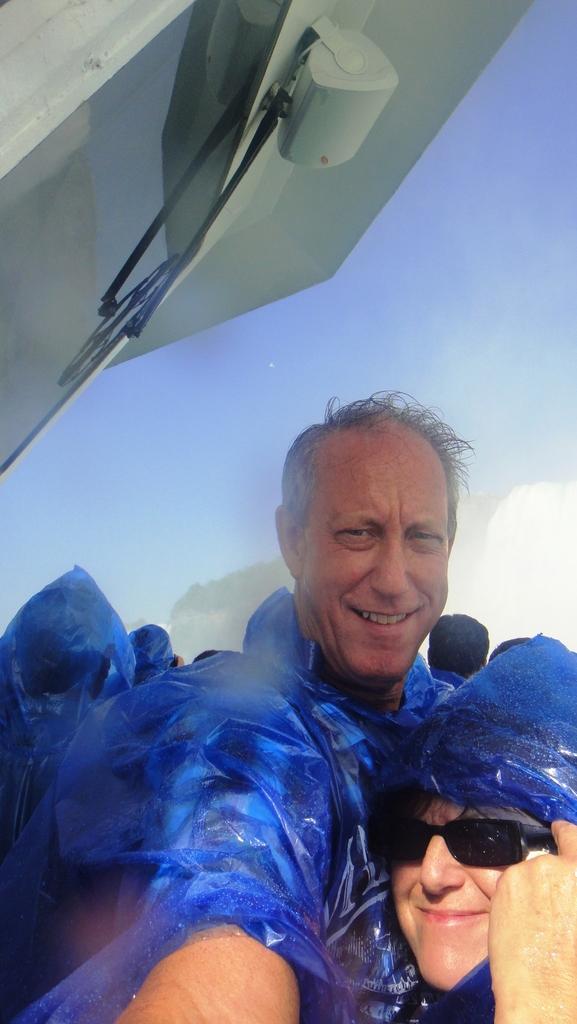In one or two sentences, can you explain what this image depicts? In this image I see 2 persons over here who are smiling and I see that this person is wearing shades and I see there are few more people in the background and few of them are wearing blue color raincoats and I see the blue sky and I see the white color thing over here. 